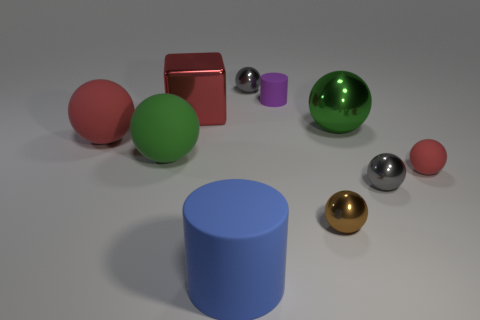Can you describe the size relationship between the objects? Certainly, the objects vary in size with the green sphere and the red cube being the largest, while the small silver sphere and the tiny purple cylinder are the smallest. The blue cylinder is medium-sized, and the golden sphere is slightly smaller than the blue cylinder.  Are there any patterns or repetition in the image? There aren't any discernible patterns or repetition in terms of arrangement or the types of objects. Each object is unique in color and size, creating a diverse collection without repetitive elements. 